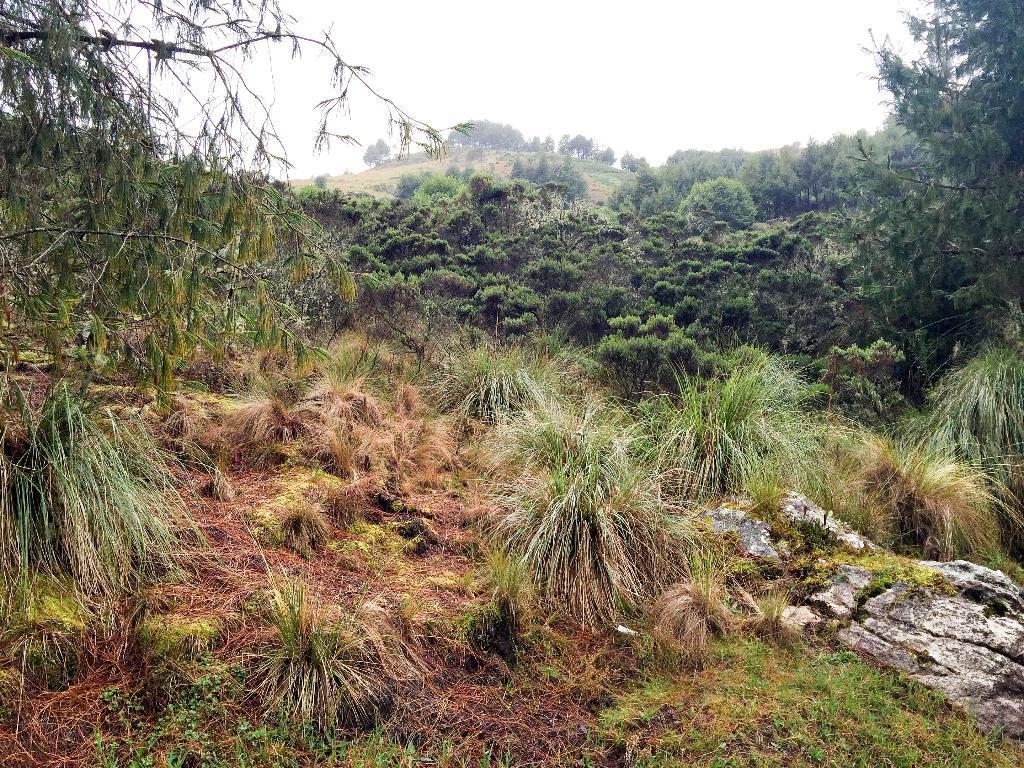Please provide a concise description of this image. In this image there is a rock. At the bottom of the image there is grass on the surface. There are plants. In the background of the image there are trees and sky. 